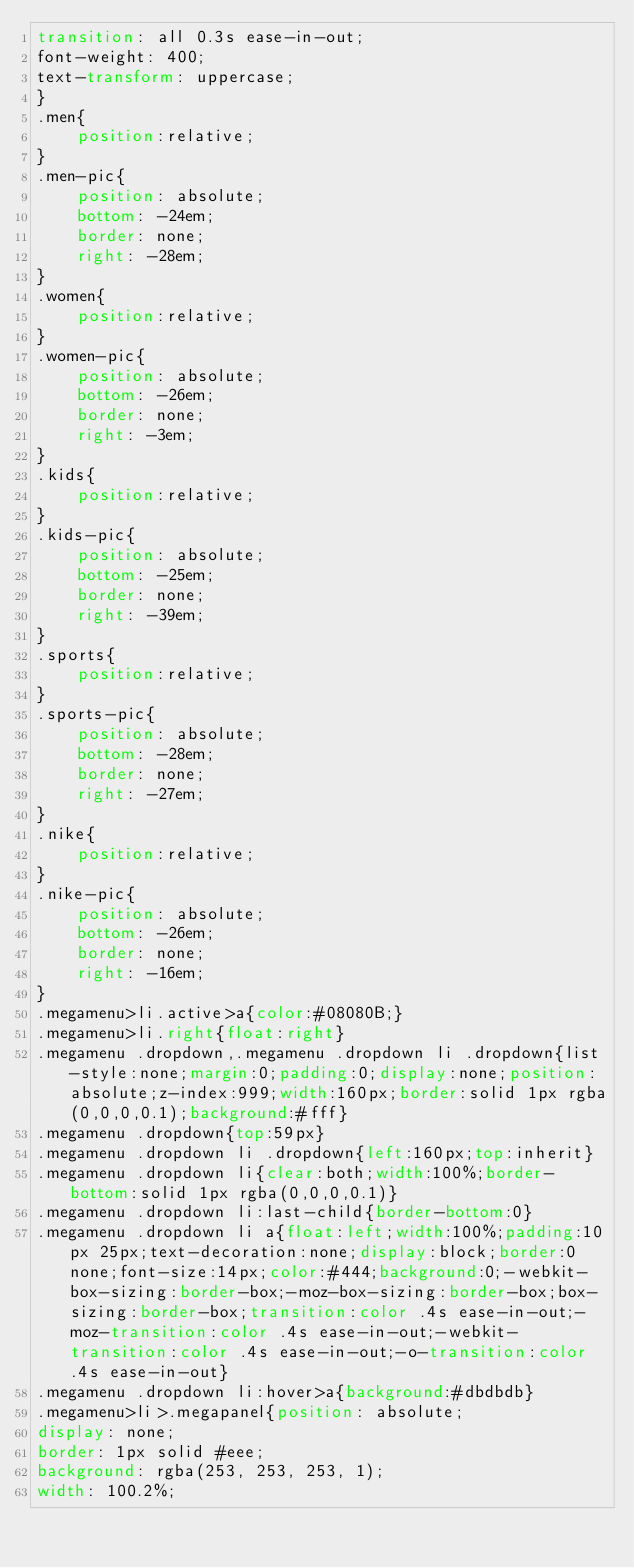<code> <loc_0><loc_0><loc_500><loc_500><_CSS_>transition: all 0.3s ease-in-out;
font-weight: 400;
text-transform: uppercase;
}
.men{
	position:relative;
}
.men-pic{
	position: absolute;
	bottom: -24em;
	border: none;
	right: -28em;
}
.women{
	position:relative;
}
.women-pic{
	position: absolute;
	bottom: -26em;
	border: none;
	right: -3em;
}
.kids{
	position:relative;
}
.kids-pic{
	position: absolute;
	bottom: -25em;
	border: none;
	right: -39em;
}
.sports{
	position:relative;
}
.sports-pic{
	position: absolute;
	bottom: -28em;
	border: none;
	right: -27em;
}
.nike{
	position:relative;
}
.nike-pic{
	position: absolute;
	bottom: -26em;
	border: none;
	right: -16em;
}
.megamenu>li.active>a{color:#08080B;}
.megamenu>li.right{float:right}
.megamenu .dropdown,.megamenu .dropdown li .dropdown{list-style:none;margin:0;padding:0;display:none;position:absolute;z-index:999;width:160px;border:solid 1px rgba(0,0,0,0.1);background:#fff}
.megamenu .dropdown{top:59px}
.megamenu .dropdown li .dropdown{left:160px;top:inherit}
.megamenu .dropdown li{clear:both;width:100%;border-bottom:solid 1px rgba(0,0,0,0.1)}
.megamenu .dropdown li:last-child{border-bottom:0}
.megamenu .dropdown li a{float:left;width:100%;padding:10px 25px;text-decoration:none;display:block;border:0 none;font-size:14px;color:#444;background:0;-webkit-box-sizing:border-box;-moz-box-sizing:border-box;box-sizing:border-box;transition:color .4s ease-in-out;-moz-transition:color .4s ease-in-out;-webkit-transition:color .4s ease-in-out;-o-transition:color .4s ease-in-out}
.megamenu .dropdown li:hover>a{background:#dbdbdb}
.megamenu>li>.megapanel{position: absolute;
display: none;
border: 1px solid #eee;
background: rgba(253, 253, 253, 1);
width: 100.2%;</code> 